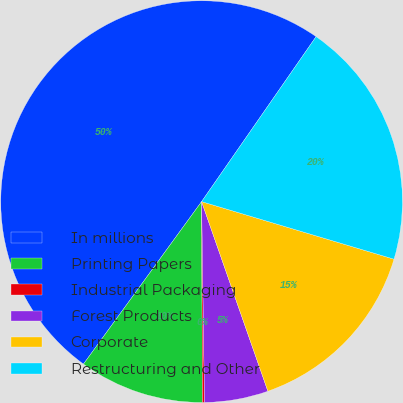Convert chart to OTSL. <chart><loc_0><loc_0><loc_500><loc_500><pie_chart><fcel>In millions<fcel>Printing Papers<fcel>Industrial Packaging<fcel>Forest Products<fcel>Corporate<fcel>Restructuring and Other<nl><fcel>49.65%<fcel>10.07%<fcel>0.17%<fcel>5.12%<fcel>15.02%<fcel>19.97%<nl></chart> 